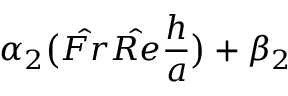Convert formula to latex. <formula><loc_0><loc_0><loc_500><loc_500>\alpha _ { 2 } \left ( \hat { F r } \hat { R e } \frac { h } { a } \right ) + \beta _ { 2 }</formula> 